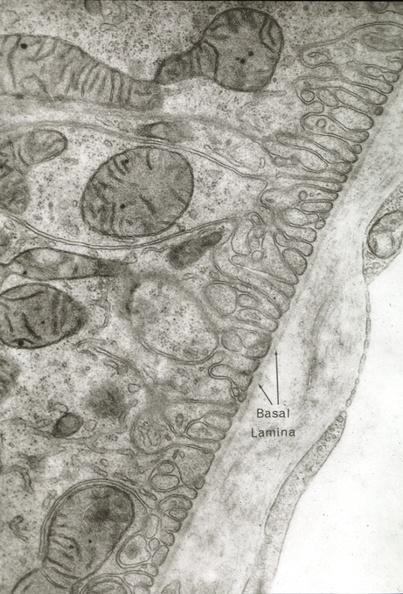what is present?
Answer the question using a single word or phrase. Vasculature 